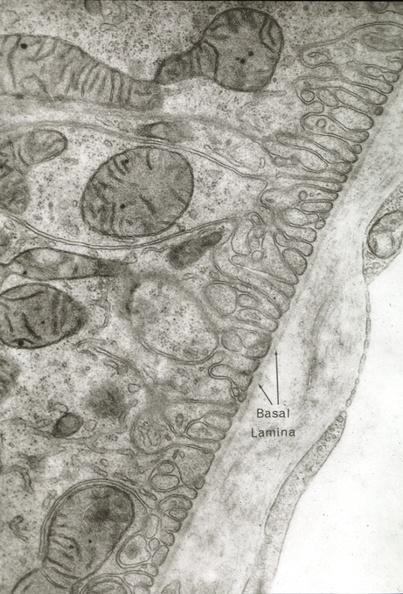what is present?
Answer the question using a single word or phrase. Vasculature 